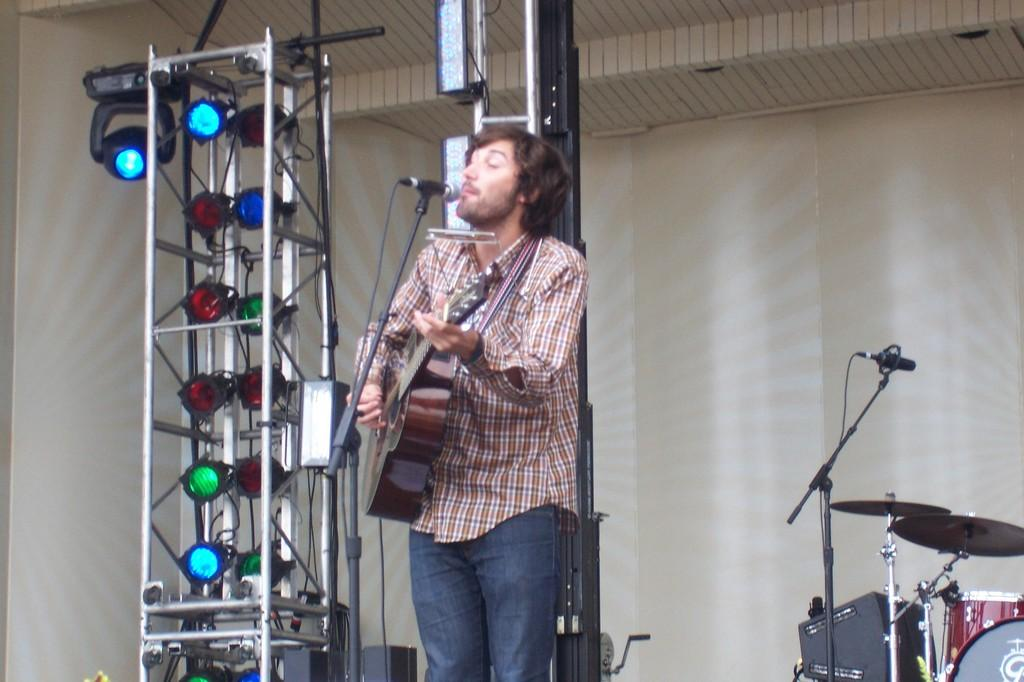What is the man in the image doing? The man is playing guitar in the image. What can be seen in the background of the image? There are mic stands, musical instruments, lights, and a wall in the background of the image. What type of nail is being used to hold the memory in place in the image? There is no memory or nail present in the image; it features a man playing guitar with various background elements. 